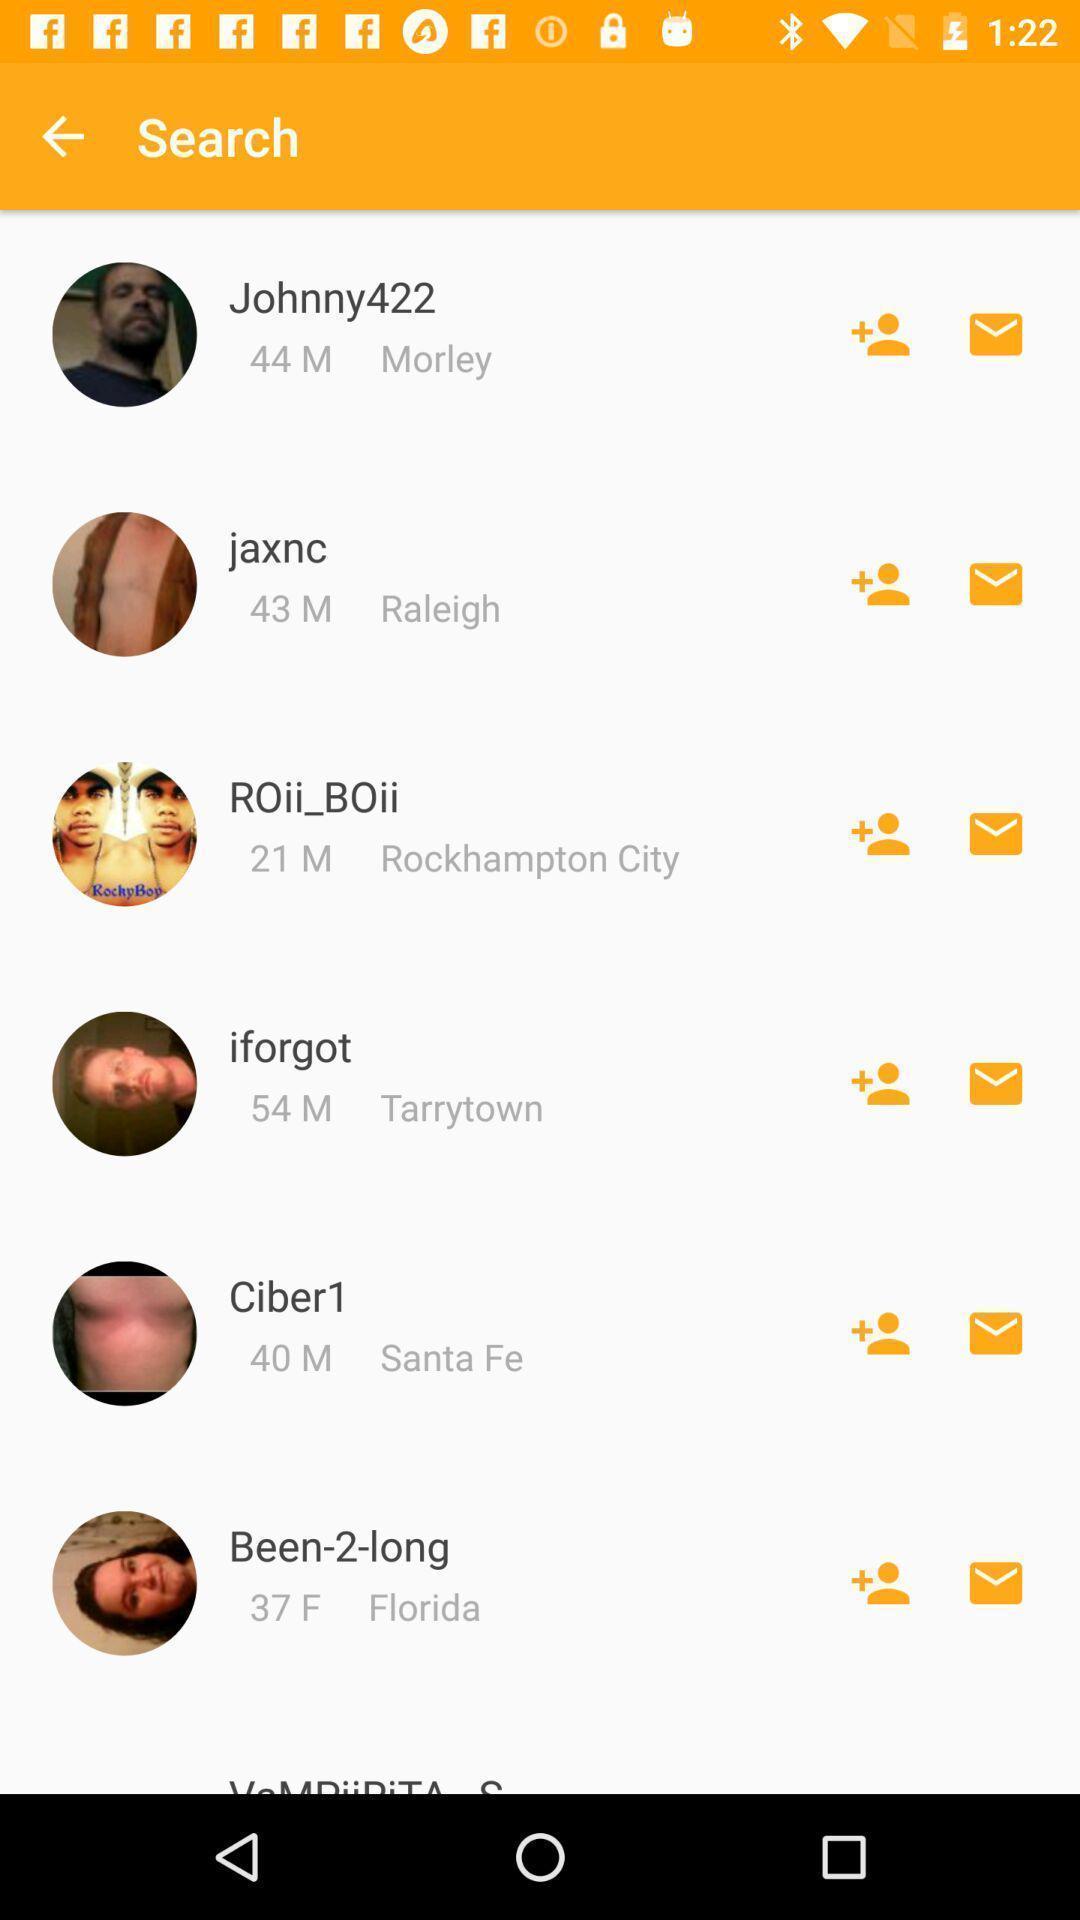Provide a textual representation of this image. Search result page showing list of profiles. 